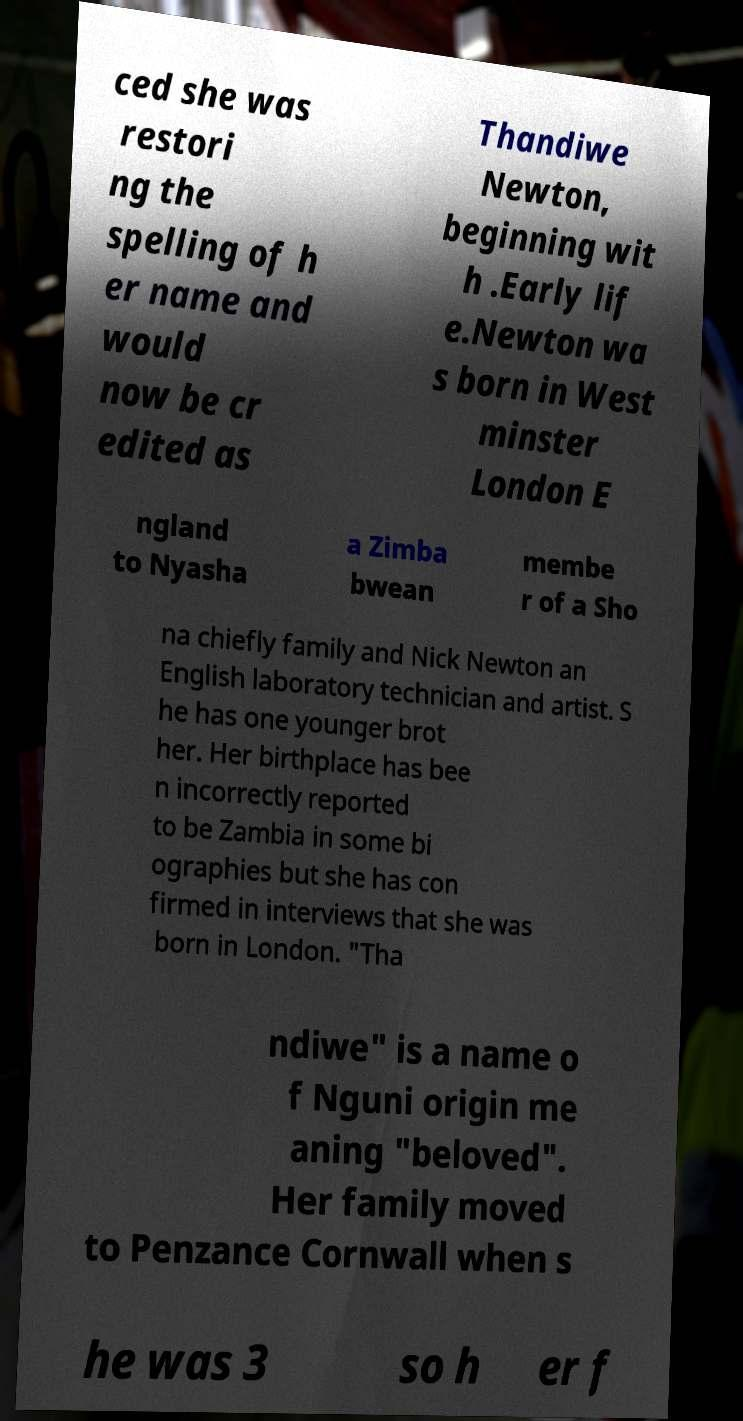Could you extract and type out the text from this image? ced she was restori ng the spelling of h er name and would now be cr edited as Thandiwe Newton, beginning wit h .Early lif e.Newton wa s born in West minster London E ngland to Nyasha a Zimba bwean membe r of a Sho na chiefly family and Nick Newton an English laboratory technician and artist. S he has one younger brot her. Her birthplace has bee n incorrectly reported to be Zambia in some bi ographies but she has con firmed in interviews that she was born in London. "Tha ndiwe" is a name o f Nguni origin me aning "beloved". Her family moved to Penzance Cornwall when s he was 3 so h er f 